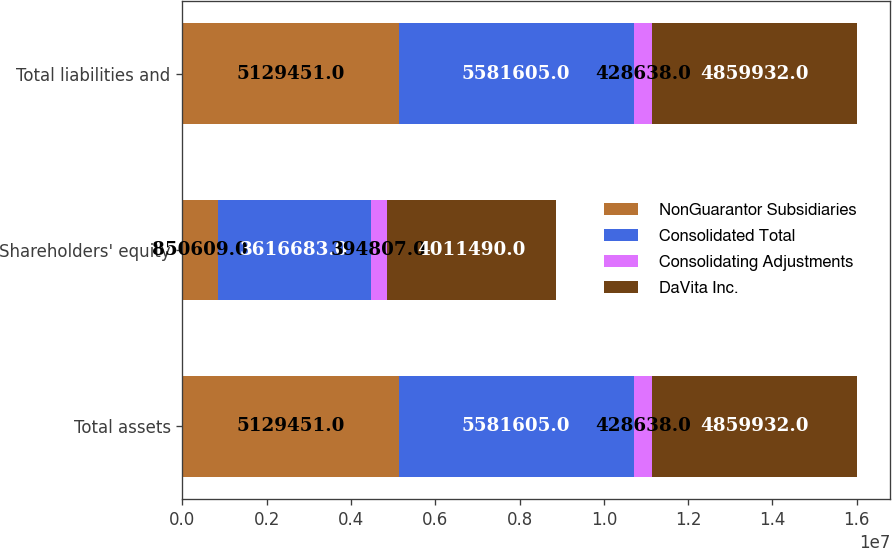Convert chart to OTSL. <chart><loc_0><loc_0><loc_500><loc_500><stacked_bar_chart><ecel><fcel>Total assets<fcel>Shareholders' equity<fcel>Total liabilities and<nl><fcel>NonGuarantor Subsidiaries<fcel>5.12945e+06<fcel>850609<fcel>5.12945e+06<nl><fcel>Consolidated Total<fcel>5.5816e+06<fcel>3.61668e+06<fcel>5.5816e+06<nl><fcel>Consolidating Adjustments<fcel>428638<fcel>394807<fcel>428638<nl><fcel>DaVita Inc.<fcel>4.85993e+06<fcel>4.01149e+06<fcel>4.85993e+06<nl></chart> 